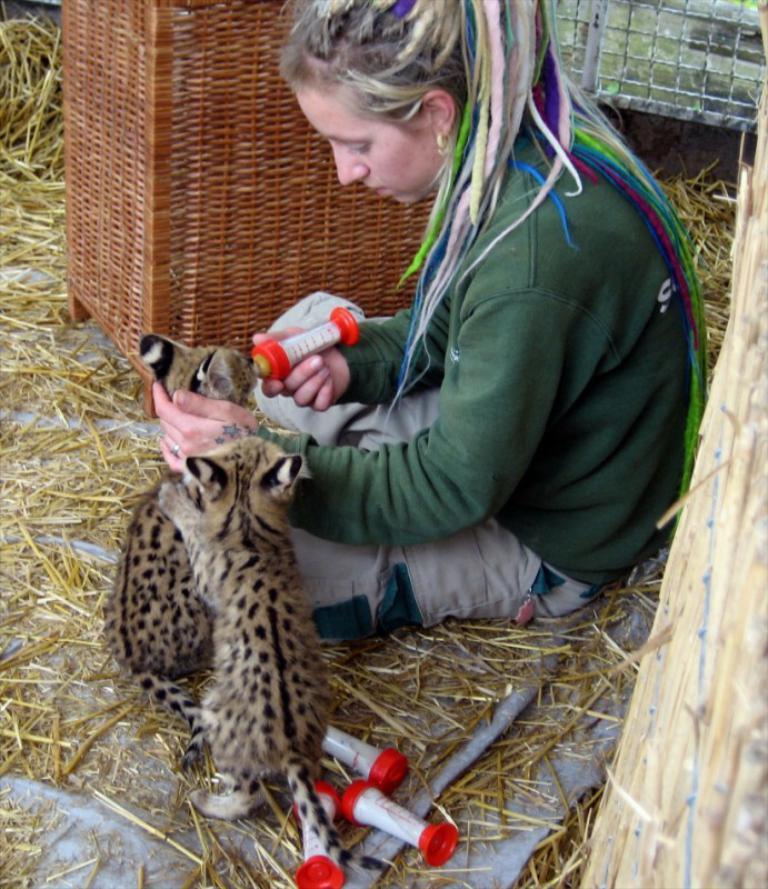Could you give a brief overview of what you see in this image? In the foreground, I can see two animals and a person is holding an object in hand is sitting on grass. In the background, I can see a wooden box, fence and plants. This image taken, maybe during a day. 